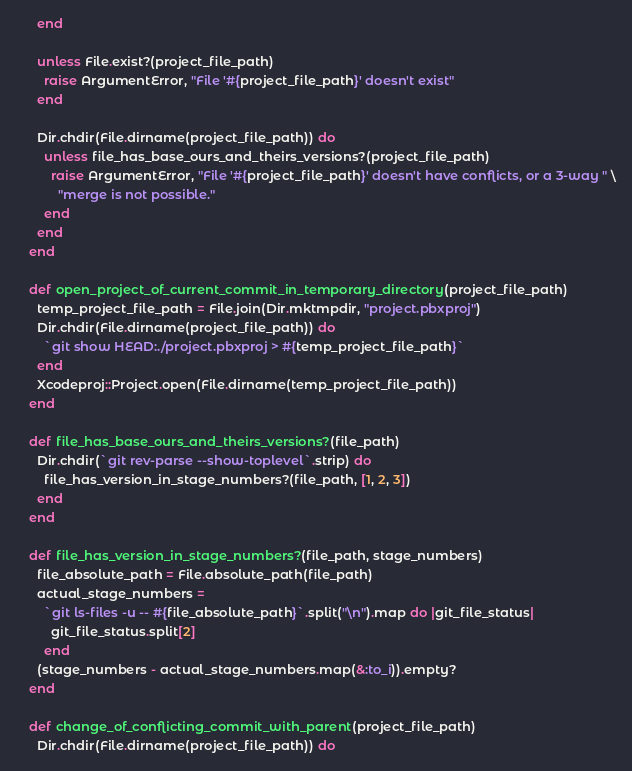<code> <loc_0><loc_0><loc_500><loc_500><_Ruby_>      end

      unless File.exist?(project_file_path)
        raise ArgumentError, "File '#{project_file_path}' doesn't exist"
      end

      Dir.chdir(File.dirname(project_file_path)) do
        unless file_has_base_ours_and_theirs_versions?(project_file_path)
          raise ArgumentError, "File '#{project_file_path}' doesn't have conflicts, or a 3-way " \
            "merge is not possible."
        end
      end
    end

    def open_project_of_current_commit_in_temporary_directory(project_file_path)
      temp_project_file_path = File.join(Dir.mktmpdir, "project.pbxproj")
      Dir.chdir(File.dirname(project_file_path)) do
        `git show HEAD:./project.pbxproj > #{temp_project_file_path}`
      end
      Xcodeproj::Project.open(File.dirname(temp_project_file_path))
    end

    def file_has_base_ours_and_theirs_versions?(file_path)
      Dir.chdir(`git rev-parse --show-toplevel`.strip) do
        file_has_version_in_stage_numbers?(file_path, [1, 2, 3])
      end
    end

    def file_has_version_in_stage_numbers?(file_path, stage_numbers)
      file_absolute_path = File.absolute_path(file_path)
      actual_stage_numbers =
        `git ls-files -u -- #{file_absolute_path}`.split("\n").map do |git_file_status|
          git_file_status.split[2]
        end
      (stage_numbers - actual_stage_numbers.map(&:to_i)).empty?
    end

    def change_of_conflicting_commit_with_parent(project_file_path)
      Dir.chdir(File.dirname(project_file_path)) do</code> 